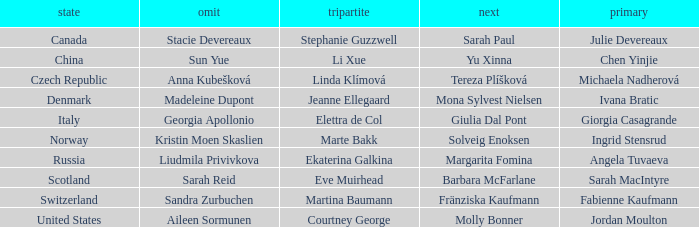What skip has denmark as the country? Madeleine Dupont. Would you mind parsing the complete table? {'header': ['state', 'omit', 'tripartite', 'next', 'primary'], 'rows': [['Canada', 'Stacie Devereaux', 'Stephanie Guzzwell', 'Sarah Paul', 'Julie Devereaux'], ['China', 'Sun Yue', 'Li Xue', 'Yu Xinna', 'Chen Yinjie'], ['Czech Republic', 'Anna Kubešková', 'Linda Klímová', 'Tereza Plíšková', 'Michaela Nadherová'], ['Denmark', 'Madeleine Dupont', 'Jeanne Ellegaard', 'Mona Sylvest Nielsen', 'Ivana Bratic'], ['Italy', 'Georgia Apollonio', 'Elettra de Col', 'Giulia Dal Pont', 'Giorgia Casagrande'], ['Norway', 'Kristin Moen Skaslien', 'Marte Bakk', 'Solveig Enoksen', 'Ingrid Stensrud'], ['Russia', 'Liudmila Privivkova', 'Ekaterina Galkina', 'Margarita Fomina', 'Angela Tuvaeva'], ['Scotland', 'Sarah Reid', 'Eve Muirhead', 'Barbara McFarlane', 'Sarah MacIntyre'], ['Switzerland', 'Sandra Zurbuchen', 'Martina Baumann', 'Fränziska Kaufmann', 'Fabienne Kaufmann'], ['United States', 'Aileen Sormunen', 'Courtney George', 'Molly Bonner', 'Jordan Moulton']]} 